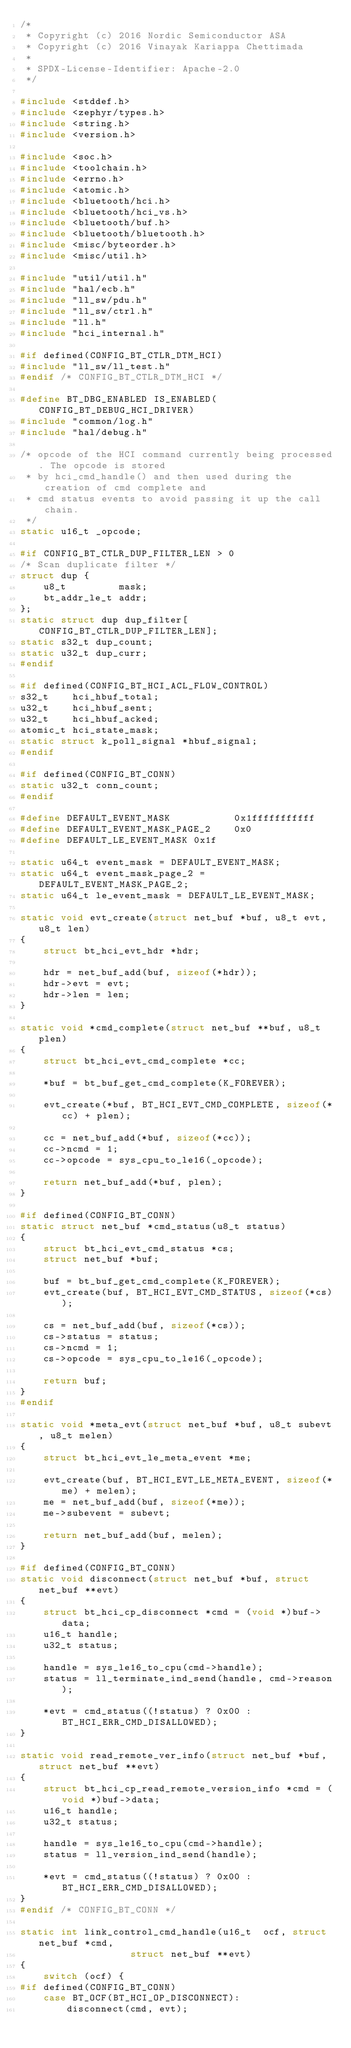Convert code to text. <code><loc_0><loc_0><loc_500><loc_500><_C_>/*
 * Copyright (c) 2016 Nordic Semiconductor ASA
 * Copyright (c) 2016 Vinayak Kariappa Chettimada
 *
 * SPDX-License-Identifier: Apache-2.0
 */

#include <stddef.h>
#include <zephyr/types.h>
#include <string.h>
#include <version.h>

#include <soc.h>
#include <toolchain.h>
#include <errno.h>
#include <atomic.h>
#include <bluetooth/hci.h>
#include <bluetooth/hci_vs.h>
#include <bluetooth/buf.h>
#include <bluetooth/bluetooth.h>
#include <misc/byteorder.h>
#include <misc/util.h>

#include "util/util.h"
#include "hal/ecb.h"
#include "ll_sw/pdu.h"
#include "ll_sw/ctrl.h"
#include "ll.h"
#include "hci_internal.h"

#if defined(CONFIG_BT_CTLR_DTM_HCI)
#include "ll_sw/ll_test.h"
#endif /* CONFIG_BT_CTLR_DTM_HCI */

#define BT_DBG_ENABLED IS_ENABLED(CONFIG_BT_DEBUG_HCI_DRIVER)
#include "common/log.h"
#include "hal/debug.h"

/* opcode of the HCI command currently being processed. The opcode is stored
 * by hci_cmd_handle() and then used during the creation of cmd complete and
 * cmd status events to avoid passing it up the call chain.
 */
static u16_t _opcode;

#if CONFIG_BT_CTLR_DUP_FILTER_LEN > 0
/* Scan duplicate filter */
struct dup {
	u8_t         mask;
	bt_addr_le_t addr;
};
static struct dup dup_filter[CONFIG_BT_CTLR_DUP_FILTER_LEN];
static s32_t dup_count;
static u32_t dup_curr;
#endif

#if defined(CONFIG_BT_HCI_ACL_FLOW_CONTROL)
s32_t    hci_hbuf_total;
u32_t    hci_hbuf_sent;
u32_t    hci_hbuf_acked;
atomic_t hci_state_mask;
static struct k_poll_signal *hbuf_signal;
#endif

#if defined(CONFIG_BT_CONN)
static u32_t conn_count;
#endif

#define DEFAULT_EVENT_MASK           0x1fffffffffff
#define DEFAULT_EVENT_MASK_PAGE_2    0x0
#define DEFAULT_LE_EVENT_MASK 0x1f

static u64_t event_mask = DEFAULT_EVENT_MASK;
static u64_t event_mask_page_2 = DEFAULT_EVENT_MASK_PAGE_2;
static u64_t le_event_mask = DEFAULT_LE_EVENT_MASK;

static void evt_create(struct net_buf *buf, u8_t evt, u8_t len)
{
	struct bt_hci_evt_hdr *hdr;

	hdr = net_buf_add(buf, sizeof(*hdr));
	hdr->evt = evt;
	hdr->len = len;
}

static void *cmd_complete(struct net_buf **buf, u8_t plen)
{
	struct bt_hci_evt_cmd_complete *cc;

	*buf = bt_buf_get_cmd_complete(K_FOREVER);

	evt_create(*buf, BT_HCI_EVT_CMD_COMPLETE, sizeof(*cc) + plen);

	cc = net_buf_add(*buf, sizeof(*cc));
	cc->ncmd = 1;
	cc->opcode = sys_cpu_to_le16(_opcode);

	return net_buf_add(*buf, plen);
}

#if defined(CONFIG_BT_CONN)
static struct net_buf *cmd_status(u8_t status)
{
	struct bt_hci_evt_cmd_status *cs;
	struct net_buf *buf;

	buf = bt_buf_get_cmd_complete(K_FOREVER);
	evt_create(buf, BT_HCI_EVT_CMD_STATUS, sizeof(*cs));

	cs = net_buf_add(buf, sizeof(*cs));
	cs->status = status;
	cs->ncmd = 1;
	cs->opcode = sys_cpu_to_le16(_opcode);

	return buf;
}
#endif

static void *meta_evt(struct net_buf *buf, u8_t subevt, u8_t melen)
{
	struct bt_hci_evt_le_meta_event *me;

	evt_create(buf, BT_HCI_EVT_LE_META_EVENT, sizeof(*me) + melen);
	me = net_buf_add(buf, sizeof(*me));
	me->subevent = subevt;

	return net_buf_add(buf, melen);
}

#if defined(CONFIG_BT_CONN)
static void disconnect(struct net_buf *buf, struct net_buf **evt)
{
	struct bt_hci_cp_disconnect *cmd = (void *)buf->data;
	u16_t handle;
	u32_t status;

	handle = sys_le16_to_cpu(cmd->handle);
	status = ll_terminate_ind_send(handle, cmd->reason);

	*evt = cmd_status((!status) ? 0x00 : BT_HCI_ERR_CMD_DISALLOWED);
}

static void read_remote_ver_info(struct net_buf *buf, struct net_buf **evt)
{
	struct bt_hci_cp_read_remote_version_info *cmd = (void *)buf->data;
	u16_t handle;
	u32_t status;

	handle = sys_le16_to_cpu(cmd->handle);
	status = ll_version_ind_send(handle);

	*evt = cmd_status((!status) ? 0x00 : BT_HCI_ERR_CMD_DISALLOWED);
}
#endif /* CONFIG_BT_CONN */

static int link_control_cmd_handle(u16_t  ocf, struct net_buf *cmd,
				   struct net_buf **evt)
{
	switch (ocf) {
#if defined(CONFIG_BT_CONN)
	case BT_OCF(BT_HCI_OP_DISCONNECT):
		disconnect(cmd, evt);</code> 